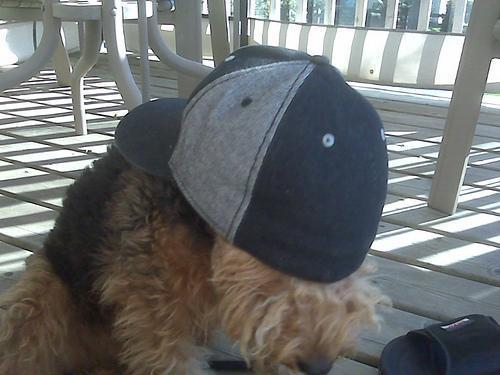How many chairs are in the photo?
Give a very brief answer. 2. 